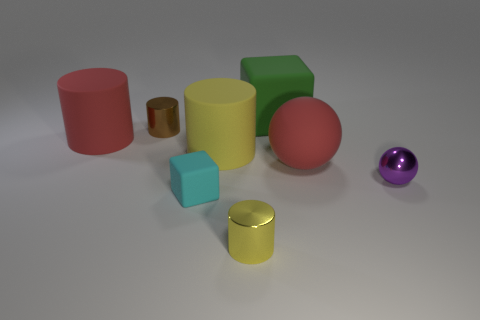There is a large object that is the same color as the rubber ball; what material is it?
Your answer should be very brief. Rubber. The cyan matte thing that is the same size as the brown metallic thing is what shape?
Your response must be concise. Cube. Are there any small matte things of the same shape as the big green matte thing?
Offer a terse response. Yes. There is a metal cylinder that is in front of the tiny purple metallic sphere; is its color the same as the rubber cylinder right of the tiny brown object?
Provide a short and direct response. Yes. Are there any brown shiny objects in front of the small rubber object?
Ensure brevity in your answer.  No. There is a big thing that is both on the right side of the yellow metal thing and in front of the green rubber object; what is its material?
Ensure brevity in your answer.  Rubber. Does the big thing that is behind the red cylinder have the same material as the cyan thing?
Ensure brevity in your answer.  Yes. What is the material of the big red sphere?
Your answer should be very brief. Rubber. There is a matte thing behind the tiny brown shiny cylinder; what size is it?
Offer a terse response. Large. Is there any other thing of the same color as the large matte sphere?
Make the answer very short. Yes. 